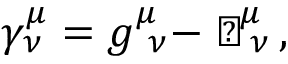<formula> <loc_0><loc_0><loc_500><loc_500>\gamma _ { \nu } ^ { \mu } = g _ { \ \nu } ^ { \mu } - \perp _ { \, \nu } ^ { \, \mu } \, ,</formula> 